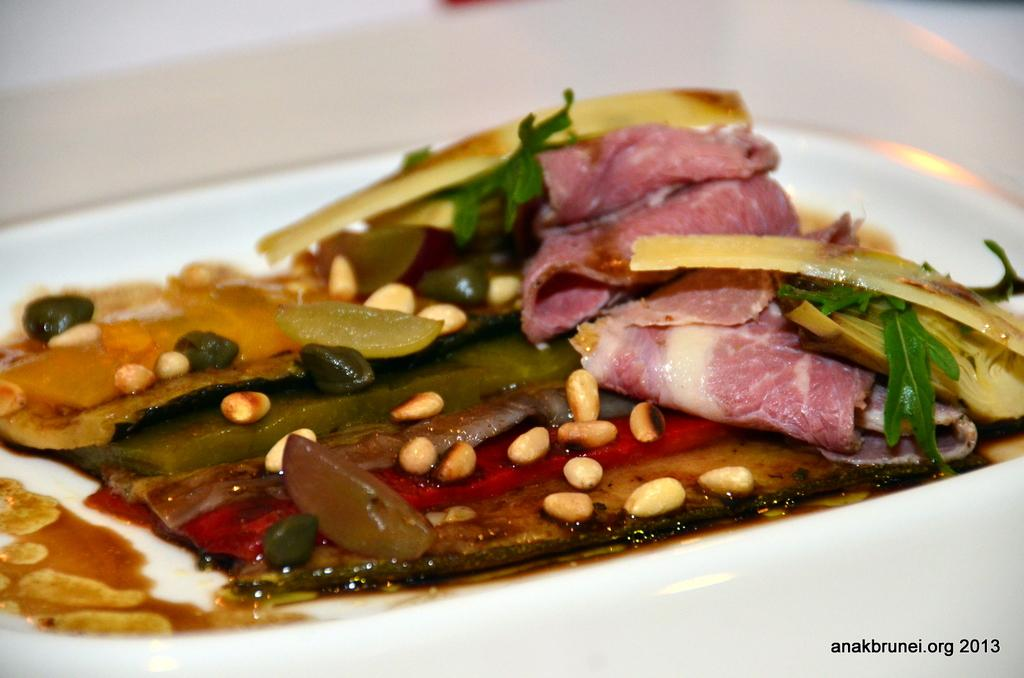What is present on the plate in the image? There is food in a plate in the image. What type of story is being told by the lizards in the image? There are no lizards present in the image, and therefore no story is being told by them. 